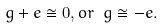Convert formula to latex. <formula><loc_0><loc_0><loc_500><loc_500>g + e \cong 0 , o r \ g \cong - e .</formula> 